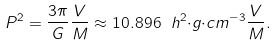<formula> <loc_0><loc_0><loc_500><loc_500>P ^ { 2 } = { \frac { 3 \pi } { G } } { \frac { V } { M } } \approx 1 0 . 8 9 6 \ h ^ { 2 } { \cdot } g { \cdot } c m ^ { - 3 } { \frac { V } { M } } .</formula> 